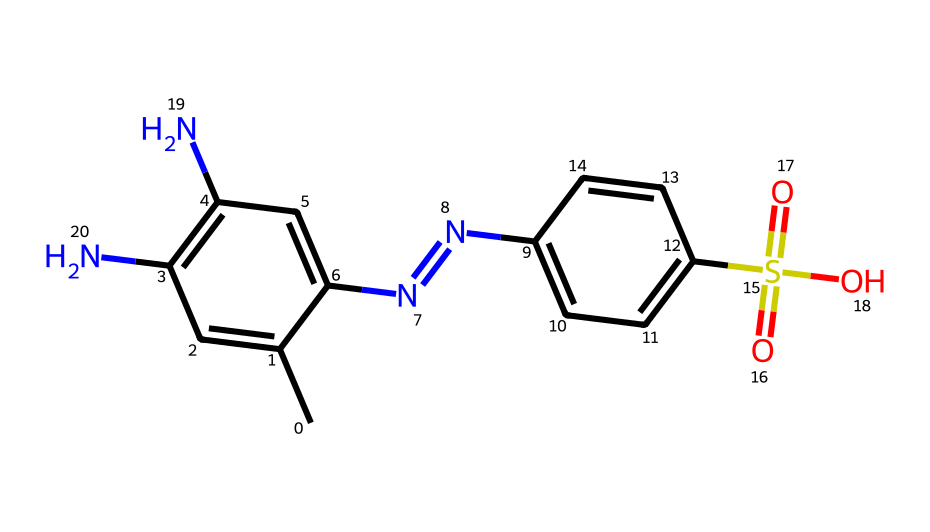What is the total number of nitrogen atoms in this structure? By analyzing the SMILES representation, we can identify that there are two nitrogen atoms present. These nitrogen atoms are indicated by the presence of "N" in the chemical structure.
Answer: 2 How many double bonds are present in this molecule? The molecule contains four double bonds, which can be observed by counting the "=" signs in the structure. Each "=" indicates a double bond.
Answer: 4 What functional group is represented by "S(=O)(=O)O"? The portion "S(=O)(=O)O" represents a sulfonic acid functional group, characterized by a sulfur atom bonded to three oxygen atoms, one of which has a hydroxyl (-OH) group.
Answer: sulfonic acid How does the structure indicate the potential for water solubility? The presence of the sulfonic acid group suggests that the molecule can interact favorably with water due to its ionic character, which enhances solubility in polar solvents.
Answer: ionic character What characteristic of this dye might suggest vibrant coloration in fabrics? The presence of multiple aromatic rings (indicated by "C=C" and the cyclic structure) is a feature commonly associated with dyes that exhibit strong color due to their ability to absorb visible light effectively.
Answer: multiple aromatic rings 